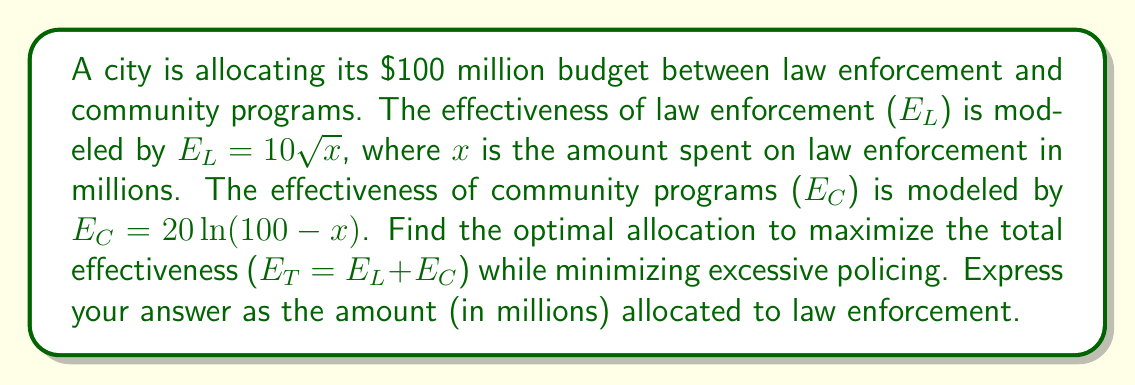Help me with this question. 1) The total effectiveness $E_T$ is given by:
   $$E_T = E_L + E_C = 10\sqrt{x} + 20\ln(100-x)$$

2) To find the maximum, we need to find where the derivative of $E_T$ with respect to $x$ equals zero:
   $$\frac{dE_T}{dx} = \frac{5}{\sqrt{x}} - \frac{20}{100-x} = 0$$

3) Multiply both sides by $\sqrt{x}(100-x)$:
   $$5(100-x) - 20\sqrt{x} = 0$$

4) Expand:
   $$500 - 5x - 20\sqrt{x} = 0$$

5) Rearrange:
   $$20\sqrt{x} = 500 - 5x$$

6) Square both sides:
   $$400x = 250000 - 5000x + 25x^2$$

7) Rearrange to standard quadratic form:
   $$25x^2 - 5400x + 250000 = 0$$

8) Solve using the quadratic formula:
   $$x = \frac{5400 \pm \sqrt{5400^2 - 4(25)(250000)}}{2(25)}$$

9) Simplify:
   $$x \approx 36.6 \text{ or } 273.4$$

10) Since $x$ represents millions of dollars and the total budget is $100 million, the only valid solution is 36.6.

This allocation balances the marginal benefits of law enforcement and community programs while favoring a more community-oriented approach, aligning with the persona's advocacy for a more lenient justice system.
Answer: $36.6 million 